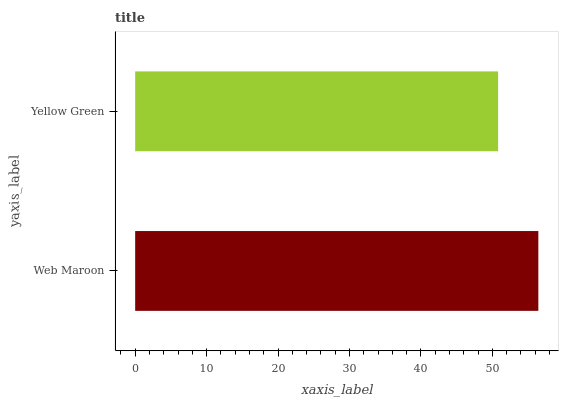Is Yellow Green the minimum?
Answer yes or no. Yes. Is Web Maroon the maximum?
Answer yes or no. Yes. Is Yellow Green the maximum?
Answer yes or no. No. Is Web Maroon greater than Yellow Green?
Answer yes or no. Yes. Is Yellow Green less than Web Maroon?
Answer yes or no. Yes. Is Yellow Green greater than Web Maroon?
Answer yes or no. No. Is Web Maroon less than Yellow Green?
Answer yes or no. No. Is Web Maroon the high median?
Answer yes or no. Yes. Is Yellow Green the low median?
Answer yes or no. Yes. Is Yellow Green the high median?
Answer yes or no. No. Is Web Maroon the low median?
Answer yes or no. No. 